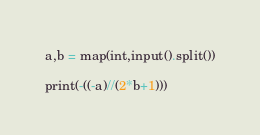<code> <loc_0><loc_0><loc_500><loc_500><_Python_>a,b = map(int,input().split())

print(-((-a)//(2*b+1)))</code> 